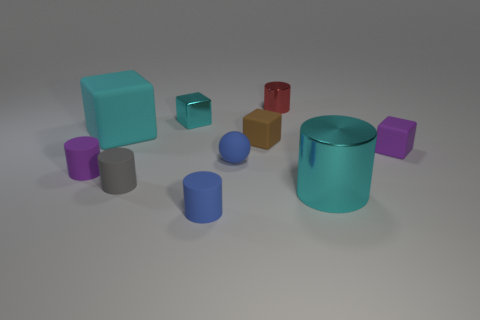Are there any blue things in front of the tiny brown object? Yes, in front of the tiny brown object, there are multiple blue items, including a cylindrical shape and a smaller spherical object. 